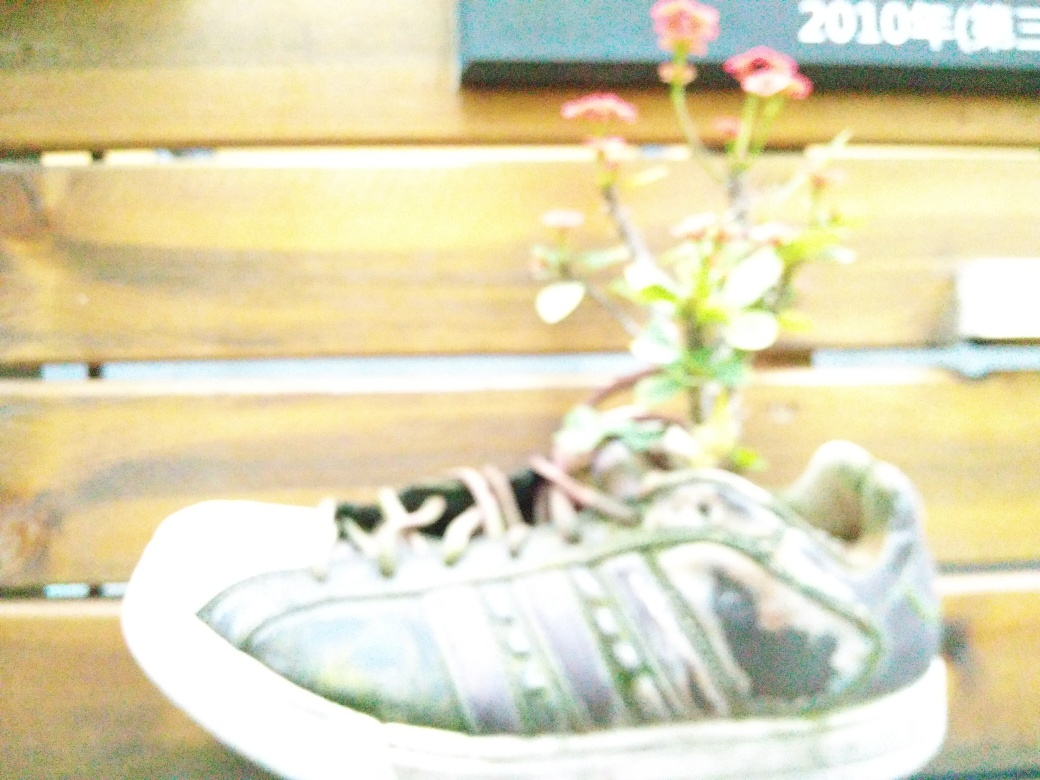Does the photo depict a pot of a plant shaped like shoes? Yes, the photo indeed shows a creative use of a shoe as a plant pot, where a plant is growing within the confines of a shoe, giving the appearance of a pot shaped like footwear. This repurposing of an everyday object into a planter makes for an intriguing piece of functional art. 